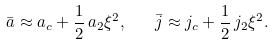<formula> <loc_0><loc_0><loc_500><loc_500>\bar { a } \approx a _ { c } + \frac { 1 } { 2 } \, a _ { 2 } \xi ^ { 2 } , \quad \bar { j } \approx j _ { c } + \frac { 1 } { 2 } \, j _ { 2 } \xi ^ { 2 } .</formula> 